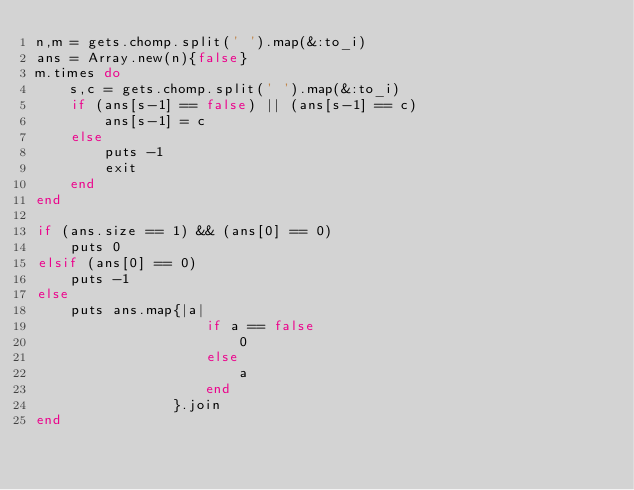Convert code to text. <code><loc_0><loc_0><loc_500><loc_500><_Ruby_>n,m = gets.chomp.split(' ').map(&:to_i)
ans = Array.new(n){false}
m.times do
    s,c = gets.chomp.split(' ').map(&:to_i)
    if (ans[s-1] == false) || (ans[s-1] == c)
        ans[s-1] = c
    else
        puts -1
        exit
    end
end

if (ans.size == 1) && (ans[0] == 0)
    puts 0
elsif (ans[0] == 0)
    puts -1
else
    puts ans.map{|a| 
                    if a == false
                        0
                    else
                        a
                    end
                }.join
end</code> 